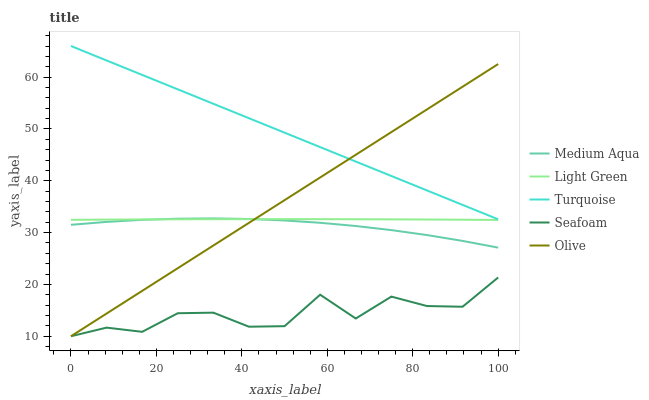Does Seafoam have the minimum area under the curve?
Answer yes or no. Yes. Does Turquoise have the maximum area under the curve?
Answer yes or no. Yes. Does Medium Aqua have the minimum area under the curve?
Answer yes or no. No. Does Medium Aqua have the maximum area under the curve?
Answer yes or no. No. Is Olive the smoothest?
Answer yes or no. Yes. Is Seafoam the roughest?
Answer yes or no. Yes. Is Turquoise the smoothest?
Answer yes or no. No. Is Turquoise the roughest?
Answer yes or no. No. Does Olive have the lowest value?
Answer yes or no. Yes. Does Medium Aqua have the lowest value?
Answer yes or no. No. Does Turquoise have the highest value?
Answer yes or no. Yes. Does Medium Aqua have the highest value?
Answer yes or no. No. Is Seafoam less than Light Green?
Answer yes or no. Yes. Is Turquoise greater than Seafoam?
Answer yes or no. Yes. Does Medium Aqua intersect Light Green?
Answer yes or no. Yes. Is Medium Aqua less than Light Green?
Answer yes or no. No. Is Medium Aqua greater than Light Green?
Answer yes or no. No. Does Seafoam intersect Light Green?
Answer yes or no. No. 